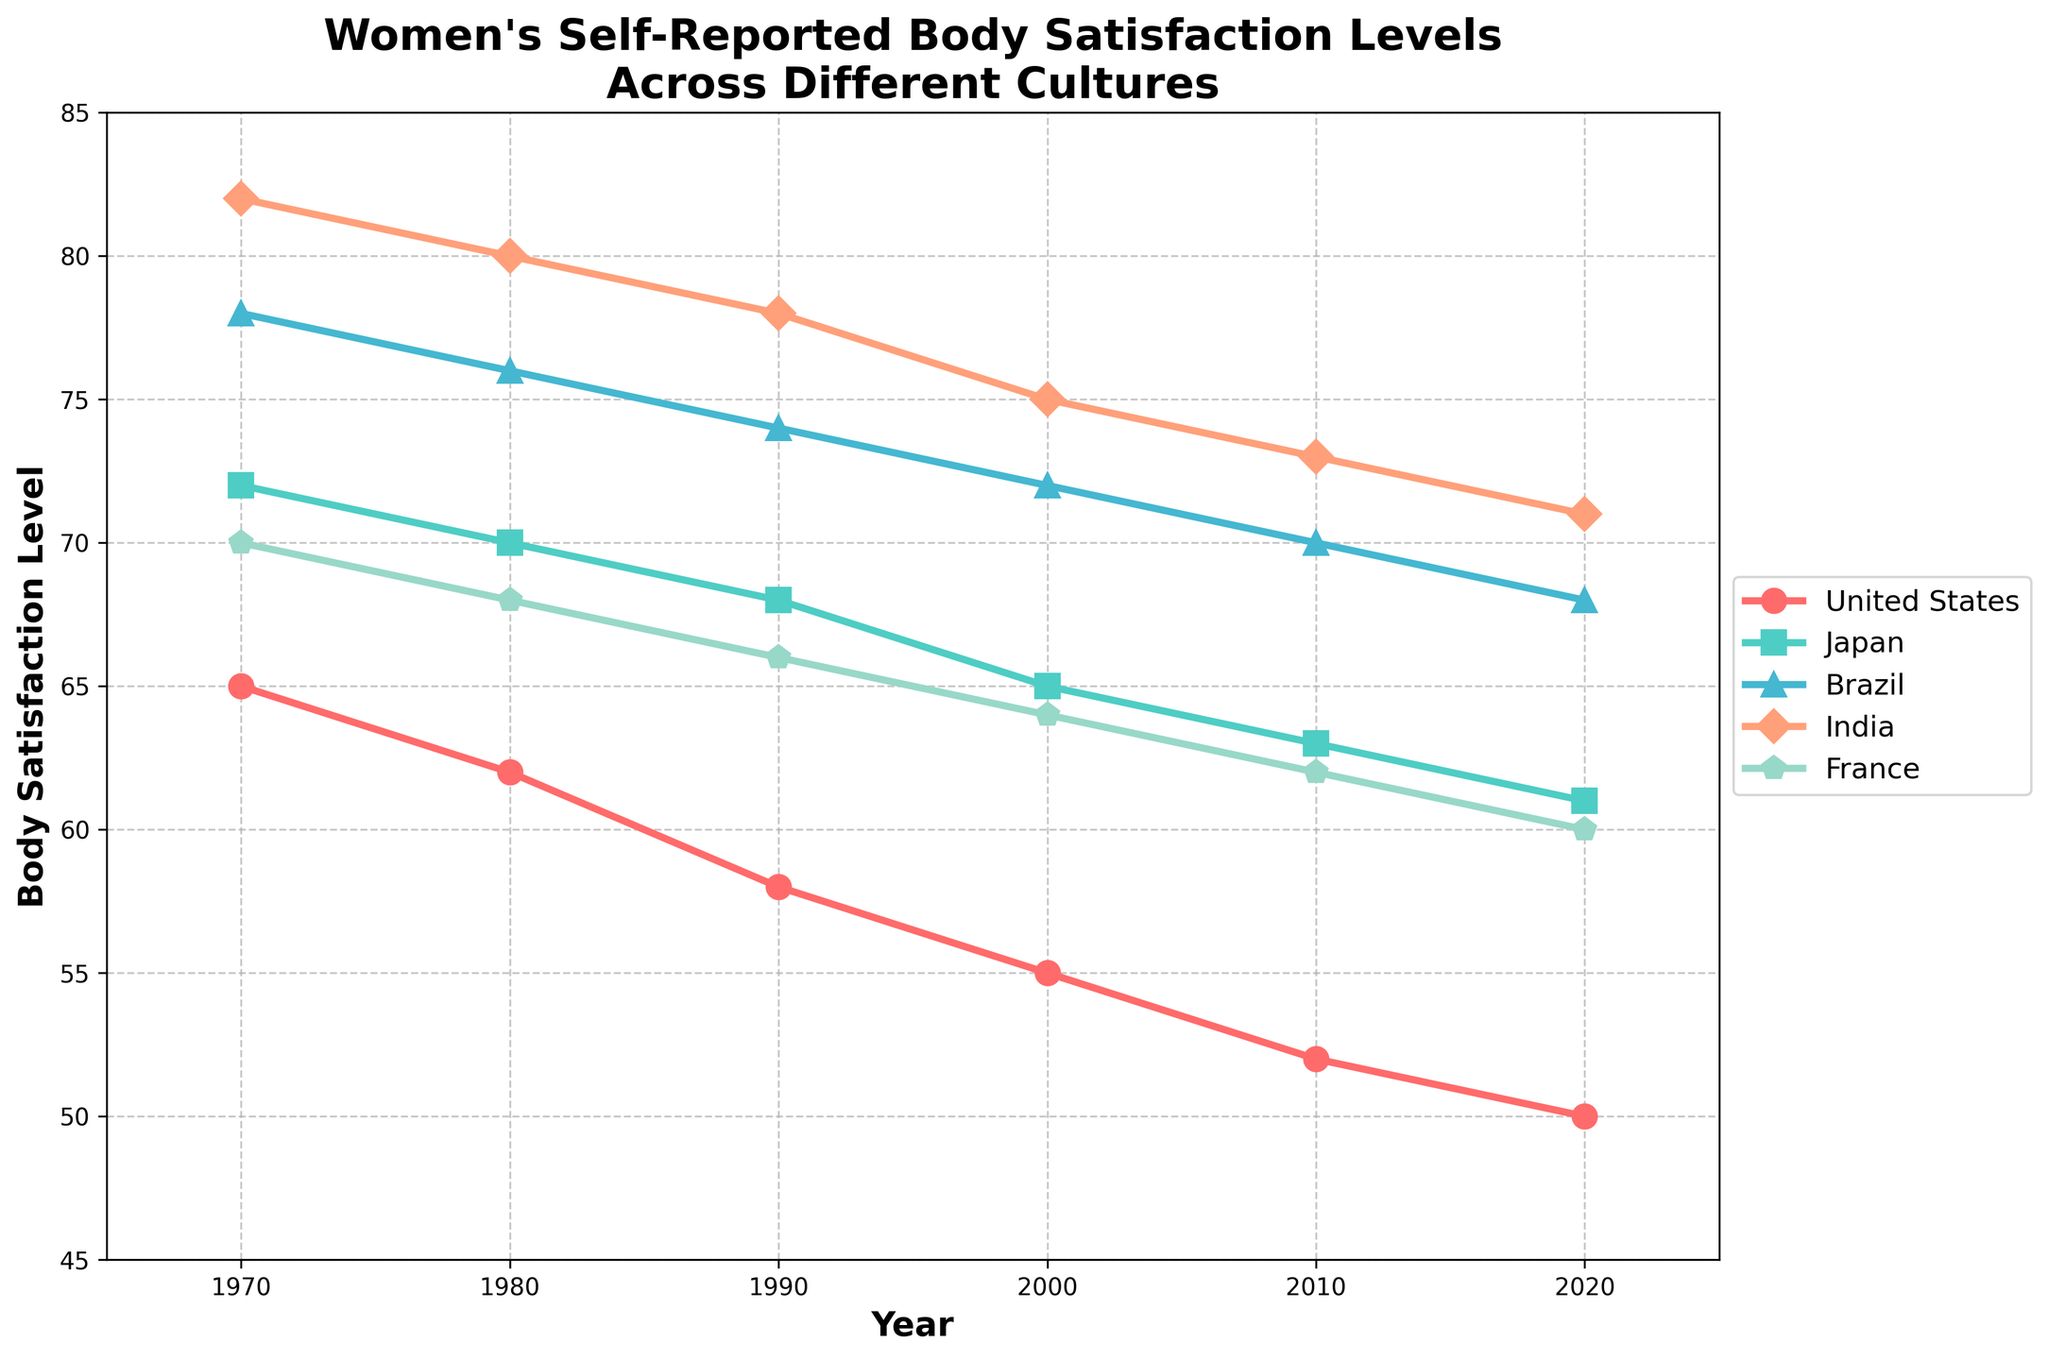What general trend can be observed in women's body satisfaction in the United States from 1970 to 2020? The plot shows a steady decline in body satisfaction levels over the years for women in the United States. Starting from 65 in 1970, it decreases gradually to 50 by 2020.
Answer: Steady decline Which country had the highest body satisfaction level in 1970, and what was the value? In 1970, India had the highest body satisfaction level. The data point on the line chart for India in 1970 is at 82.
Answer: India, 82 Between 2010 and 2020, which country experienced the largest drop in body satisfaction levels? Subtract the 2020 body satisfaction level from the 2010 level for each country: 
United States: 52 - 50 = 2
Japan: 63 - 61 = 2
Brazil: 70 - 68 = 2
India: 73 - 71 = 2
France: 62 - 60 = 2
Each country experienced an equal drop of 2 points.
Answer: All countries, 2 points What is the average body satisfaction level in France from 1970 to 2020? Add all the data points for France and then divide by the number of data points:
(70 + 68 + 66 + 64 + 62 + 60) = 390
390 / 6 = 65
Answer: 65 Which country shows the least variation in body satisfaction levels over the years? To determine the variation, calculate the range (max - min) for each country:
United States: 65 - 50 = 15
Japan: 72 - 61 = 11
Brazil: 78 - 68 = 10
India: 82 - 71 = 11
France: 70 - 60 = 10
Both Brazil and France show the least variation with a range of 10.
Answer: Brazil and France, 10 How does the trend in Japan compare to that in Brazil from 1970 to 2020? Both countries show a downward trend in body satisfaction levels over the years. However, Japan starts at a higher body satisfaction level than Brazil in 1970 (72 vs. 78) but ends at a lower point in 2020 (61 vs. 68).
Answer: Both have downward trends; Japan starts higher and ends lower What can be inferred about the overall trends in body satisfaction across all the countries? Each country shows a decreasing trend in body satisfaction from 1970 to 2020, regardless of the starting and ending values. This reflects a universal decline in self-reported body satisfaction levels among women in these cultures over the 50 years.
Answer: Universal decline What are the body satisfaction levels for India and France in 2000, and which country has a higher value? Check the 2000 data points for India and France: 
India: 75
France: 64
India has a higher body satisfaction level than France in 2000.
Answer: India, 75 Comparing the years 1970 and 2020, which country shows the smallest decrease in body satisfaction? Calculate the difference from 1970 to 2020 for each country:
United States: 65 - 50 = 15
Japan: 72 - 61 = 11
Brazil: 78 - 68 = 10
India: 82 - 71 = 11
France: 70 - 60 = 10
Both Brazil and France have the smallest decrease of 10 points.
Answer: Brazil and France, 10 points 